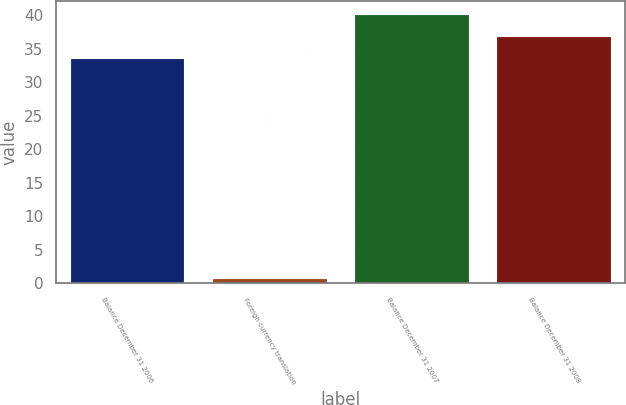<chart> <loc_0><loc_0><loc_500><loc_500><bar_chart><fcel>Balance December 31 2006<fcel>Foreign currency translation<fcel>Balance December 31 2007<fcel>Balance December 31 2008<nl><fcel>33.4<fcel>0.7<fcel>40.08<fcel>36.74<nl></chart> 